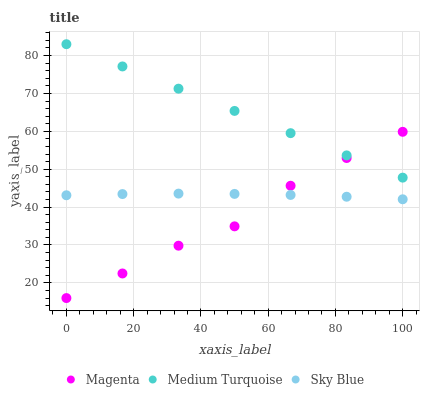Does Magenta have the minimum area under the curve?
Answer yes or no. Yes. Does Medium Turquoise have the maximum area under the curve?
Answer yes or no. Yes. Does Medium Turquoise have the minimum area under the curve?
Answer yes or no. No. Does Magenta have the maximum area under the curve?
Answer yes or no. No. Is Medium Turquoise the smoothest?
Answer yes or no. Yes. Is Magenta the roughest?
Answer yes or no. Yes. Is Magenta the smoothest?
Answer yes or no. No. Is Medium Turquoise the roughest?
Answer yes or no. No. Does Magenta have the lowest value?
Answer yes or no. Yes. Does Medium Turquoise have the lowest value?
Answer yes or no. No. Does Medium Turquoise have the highest value?
Answer yes or no. Yes. Does Magenta have the highest value?
Answer yes or no. No. Is Sky Blue less than Medium Turquoise?
Answer yes or no. Yes. Is Medium Turquoise greater than Sky Blue?
Answer yes or no. Yes. Does Magenta intersect Medium Turquoise?
Answer yes or no. Yes. Is Magenta less than Medium Turquoise?
Answer yes or no. No. Is Magenta greater than Medium Turquoise?
Answer yes or no. No. Does Sky Blue intersect Medium Turquoise?
Answer yes or no. No. 